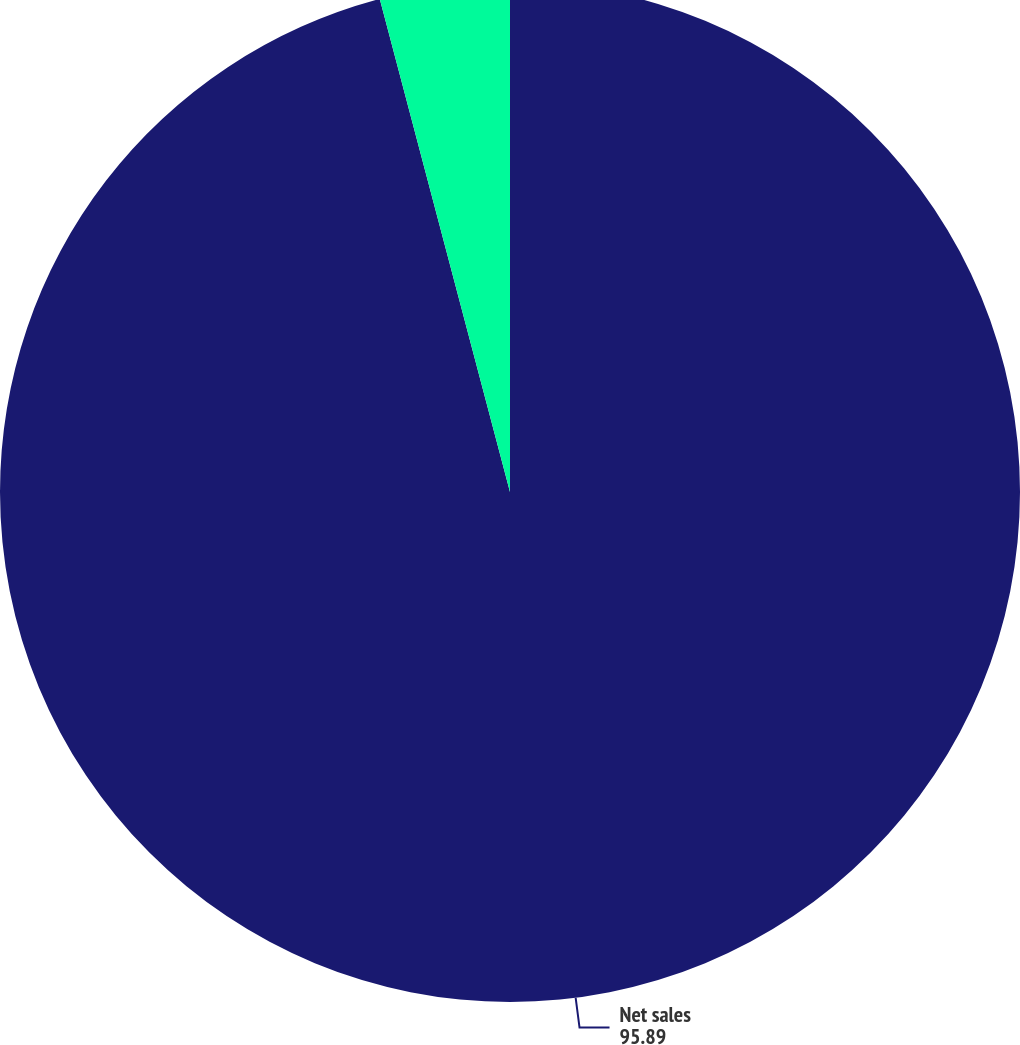<chart> <loc_0><loc_0><loc_500><loc_500><pie_chart><fcel>Net sales<fcel>Segment profit<nl><fcel>95.89%<fcel>4.11%<nl></chart> 